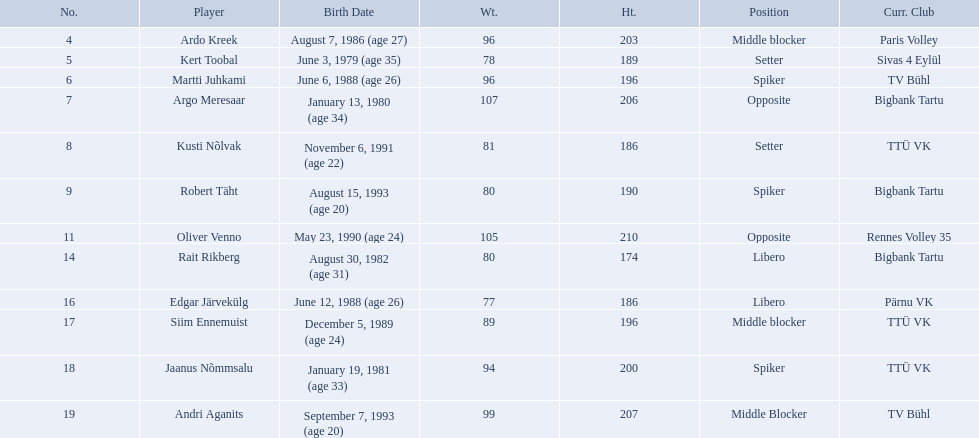Who are the players of the estonian men's national volleyball team? Ardo Kreek, Kert Toobal, Martti Juhkami, Argo Meresaar, Kusti Nõlvak, Robert Täht, Oliver Venno, Rait Rikberg, Edgar Järvekülg, Siim Ennemuist, Jaanus Nõmmsalu, Andri Aganits. Of these, which have a height over 200? Ardo Kreek, Argo Meresaar, Oliver Venno, Andri Aganits. Of the remaining, who is the tallest? Oliver Venno. 